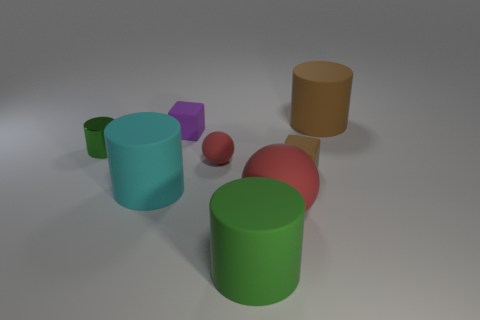Add 2 small matte blocks. How many objects exist? 10 Subtract all blocks. How many objects are left? 6 Add 7 brown blocks. How many brown blocks are left? 8 Add 8 cyan rubber cylinders. How many cyan rubber cylinders exist? 9 Subtract 0 red cylinders. How many objects are left? 8 Subtract all tiny brown things. Subtract all brown matte spheres. How many objects are left? 7 